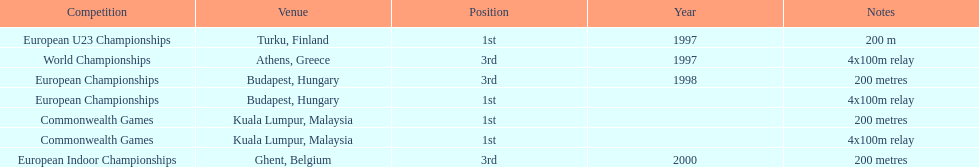How many 4x 100m relays were run? 3. 